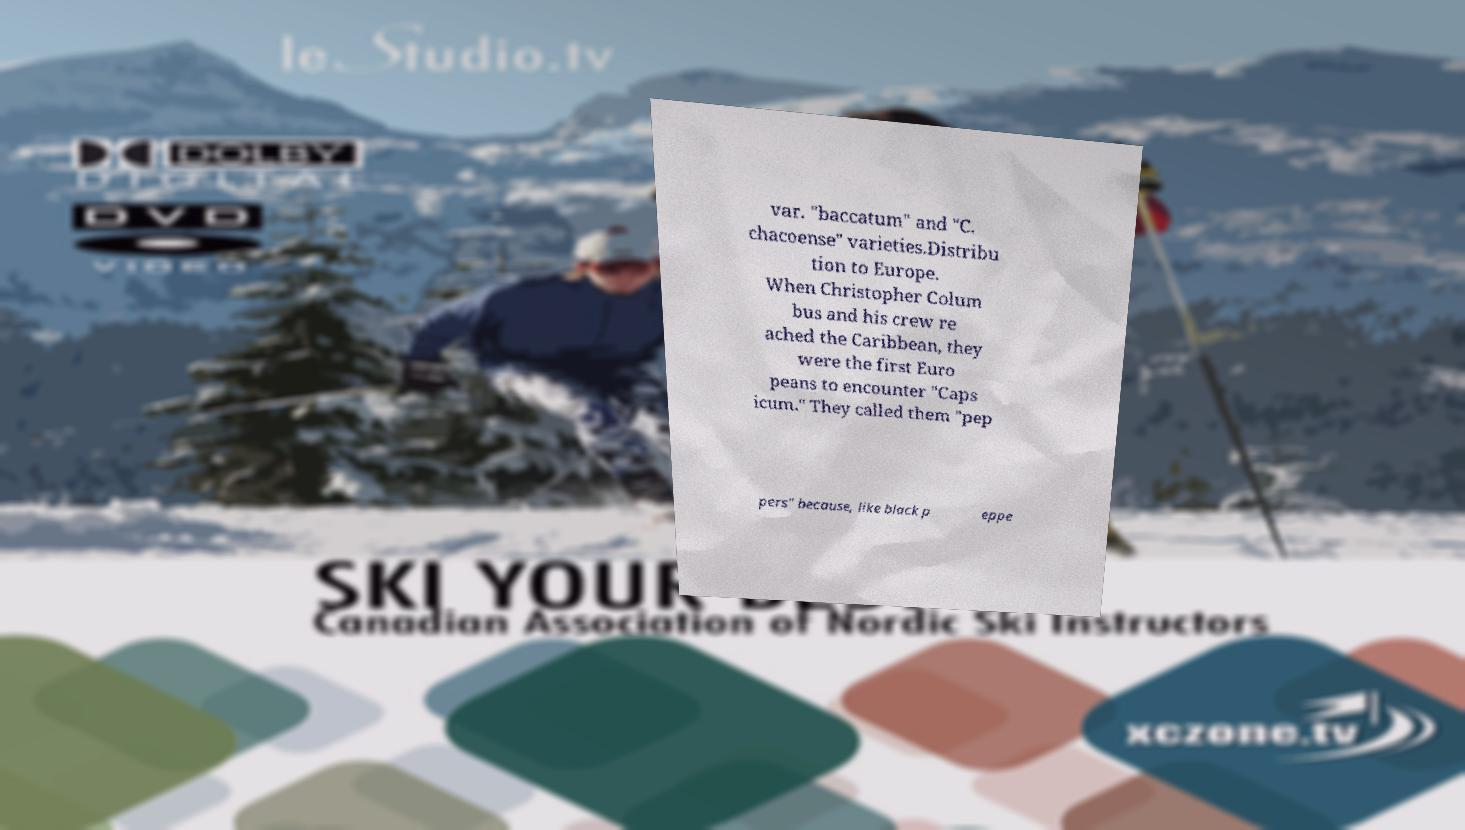For documentation purposes, I need the text within this image transcribed. Could you provide that? var. "baccatum" and "C. chacoense" varieties.Distribu tion to Europe. When Christopher Colum bus and his crew re ached the Caribbean, they were the first Euro peans to encounter "Caps icum." They called them "pep pers" because, like black p eppe 